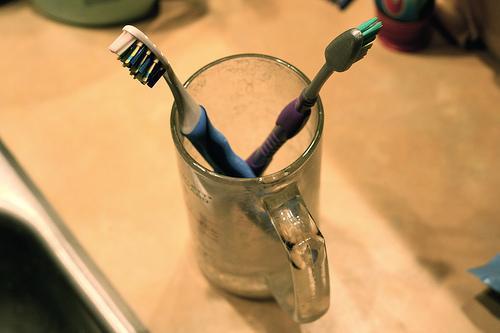How many toothbrushes are in the scene?
Give a very brief answer. 2. 